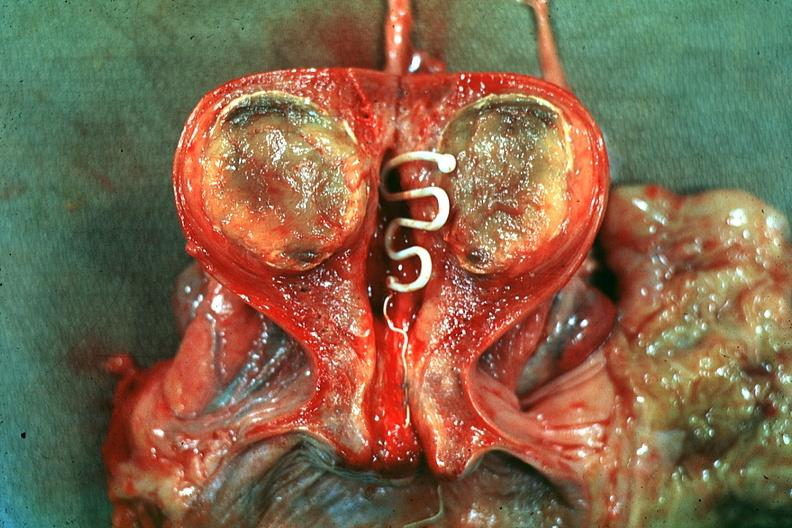what is present?
Answer the question using a single word or phrase. Female reproductive 